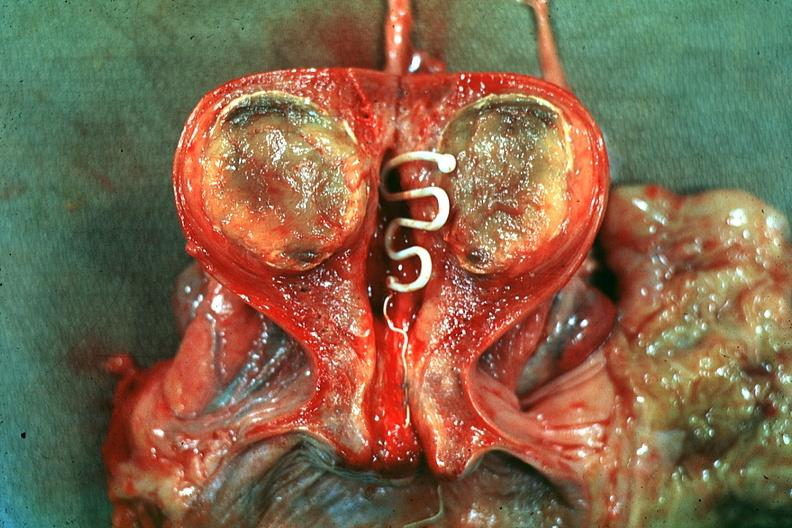what is present?
Answer the question using a single word or phrase. Female reproductive 